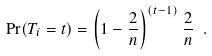<formula> <loc_0><loc_0><loc_500><loc_500>\Pr ( T _ { i } = t ) = \left ( 1 - \frac { 2 } { n } \right ) ^ { ( t - 1 ) } \frac { 2 } { n } \ .</formula> 